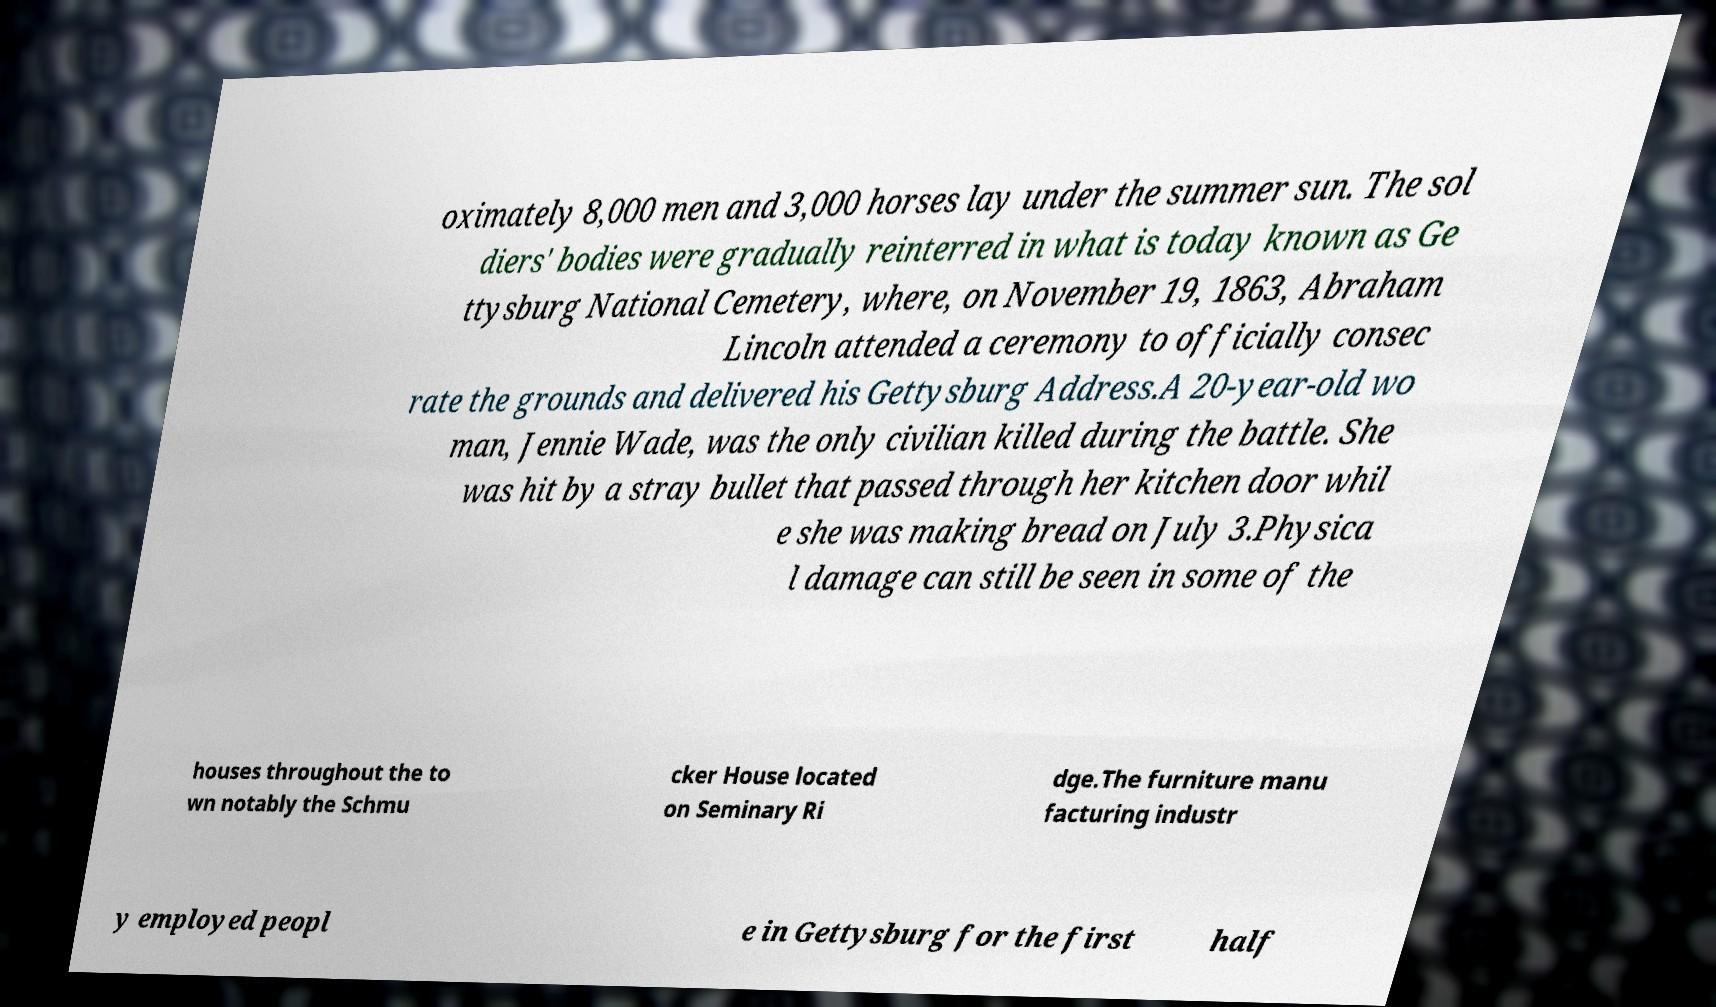Could you assist in decoding the text presented in this image and type it out clearly? oximately 8,000 men and 3,000 horses lay under the summer sun. The sol diers' bodies were gradually reinterred in what is today known as Ge ttysburg National Cemetery, where, on November 19, 1863, Abraham Lincoln attended a ceremony to officially consec rate the grounds and delivered his Gettysburg Address.A 20-year-old wo man, Jennie Wade, was the only civilian killed during the battle. She was hit by a stray bullet that passed through her kitchen door whil e she was making bread on July 3.Physica l damage can still be seen in some of the houses throughout the to wn notably the Schmu cker House located on Seminary Ri dge.The furniture manu facturing industr y employed peopl e in Gettysburg for the first half 